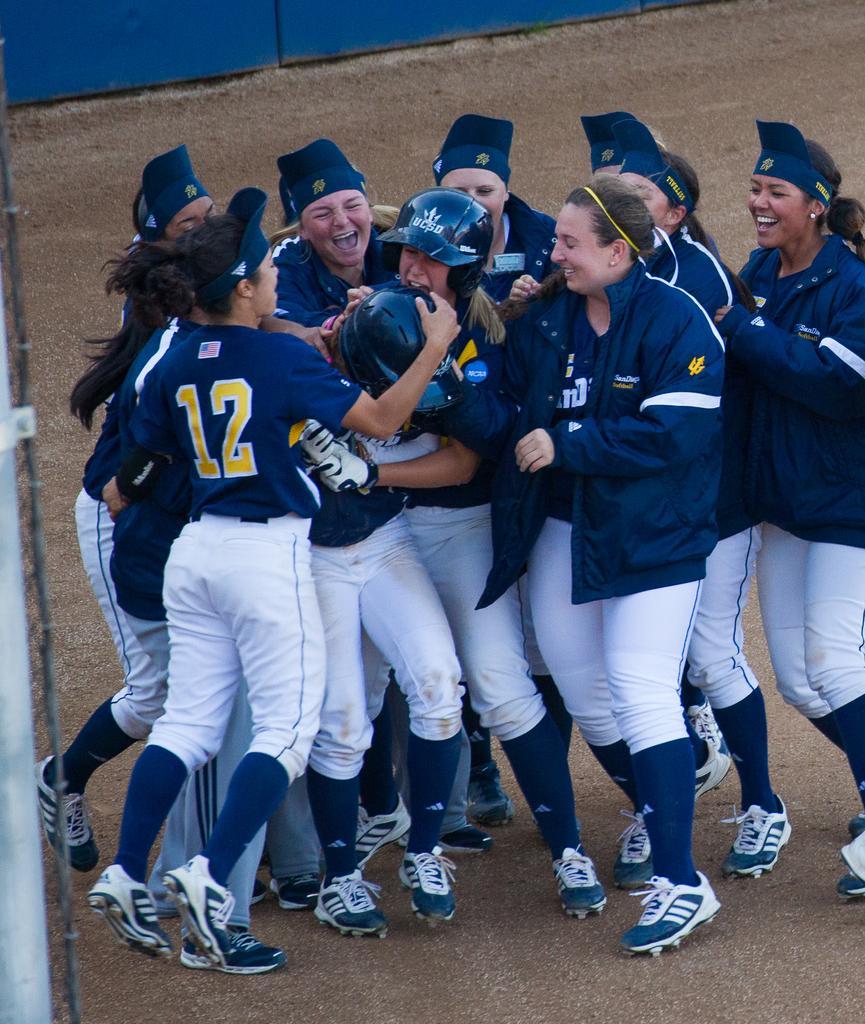Could you give a brief overview of what you see in this image? In the foreground, I can see a group of women´s on the ground. In the background, I can see a fence. This image is taken, maybe during a day. 